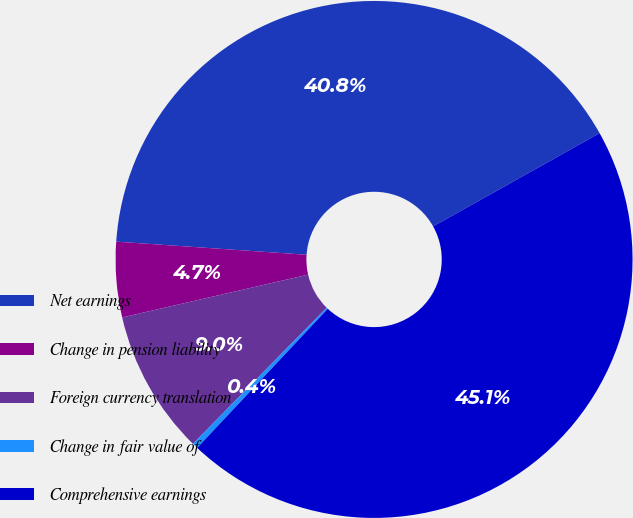<chart> <loc_0><loc_0><loc_500><loc_500><pie_chart><fcel>Net earnings<fcel>Change in pension liability<fcel>Foreign currency translation<fcel>Change in fair value of<fcel>Comprehensive earnings<nl><fcel>40.78%<fcel>4.7%<fcel>9.04%<fcel>0.36%<fcel>45.12%<nl></chart> 